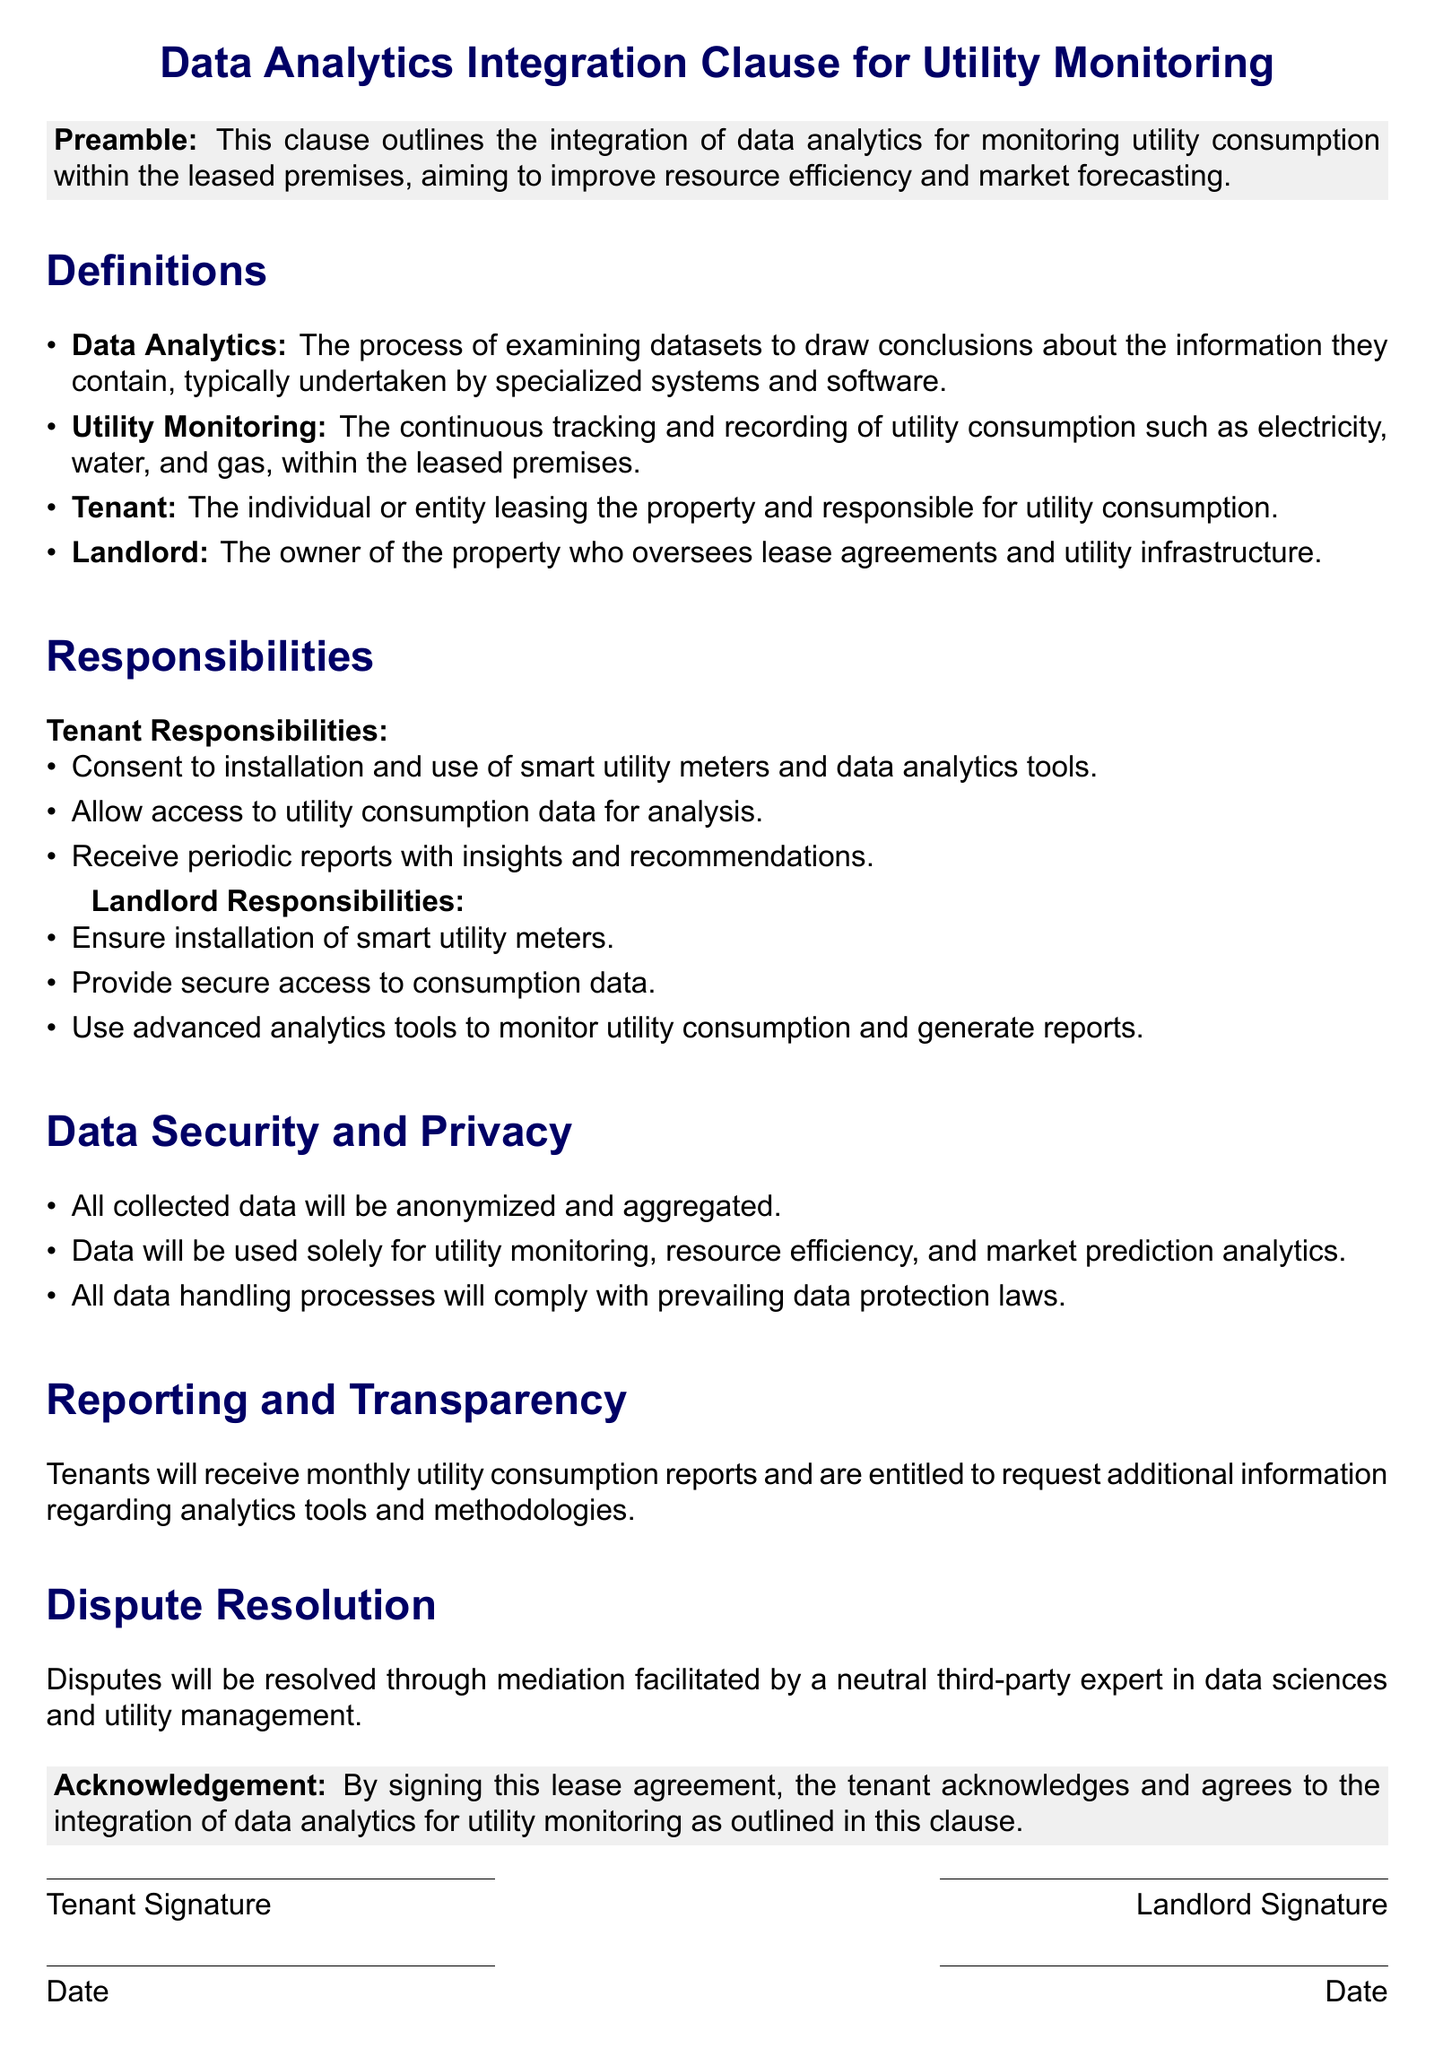What is the title of the clause? The title of the clause is prominently displayed at the top of the document, denoting the specific focus of the agreement.
Answer: Data Analytics Integration Clause for Utility Monitoring Who is responsible for the installation of smart utility meters? This information can be found under the Landlord Responsibilities section, outlining specific duties assigned to the landlord.
Answer: Landlord What is defined as Data Analytics? The definition is provided in the Definitions section, explaining the concept of data analysis in a straightforward manner.
Answer: The process of examining datasets to draw conclusions about the information they contain How often will tenants receive utility consumption reports? The reporting frequency is mentioned in the Reporting and Transparency section, highlighting the regularity of the information provided to tenants.
Answer: Monthly What legal aspect is highlighted under Data Security and Privacy? This detail emphasizes compliance, which is crucial for legal protections concerning data handling practices.
Answer: Prevailing data protection laws What is required of tenants regarding data usage consent? This obligation is explicitly stated in the Tenant Responsibilities section, showing the tenant's role in the data analytics process.
Answer: Consent to installation and use of smart utility meters and data analytics tools How will disputes be resolved according to the document? The method for resolving disputes is specified in the Dispute Resolution section, indicating the preferred approach to conflicts arising from the lease.
Answer: Mediation What type of data will be collected according to the clause? This is clarified in the Data Security and Privacy section, which specifies the nature of the data to be collected and used.
Answer: Utility consumption data Who facilitates the mediation in case of disputes? This detail indicates the qualifications of the mediator mentioned in the Dispute Resolution section, focusing on expertise.
Answer: A neutral third-party expert in data sciences and utility management 